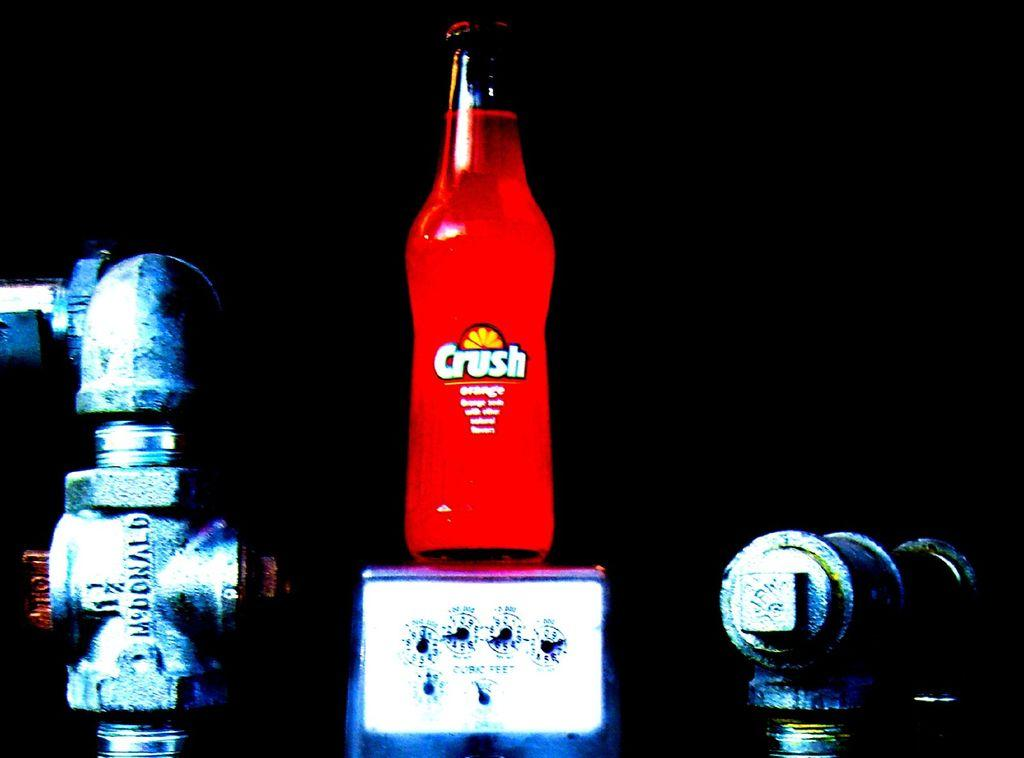<image>
Share a concise interpretation of the image provided. A bottle of orange crush stands on top of a scale being weighed 